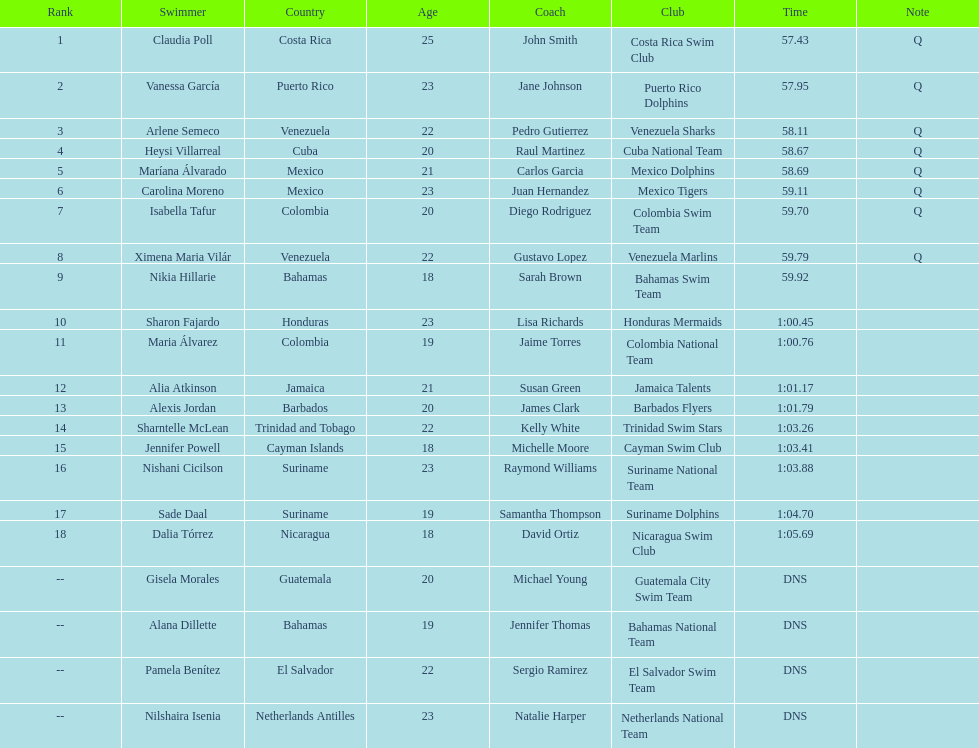Who was the last competitor to actually finish the preliminaries? Dalia Tórrez. 